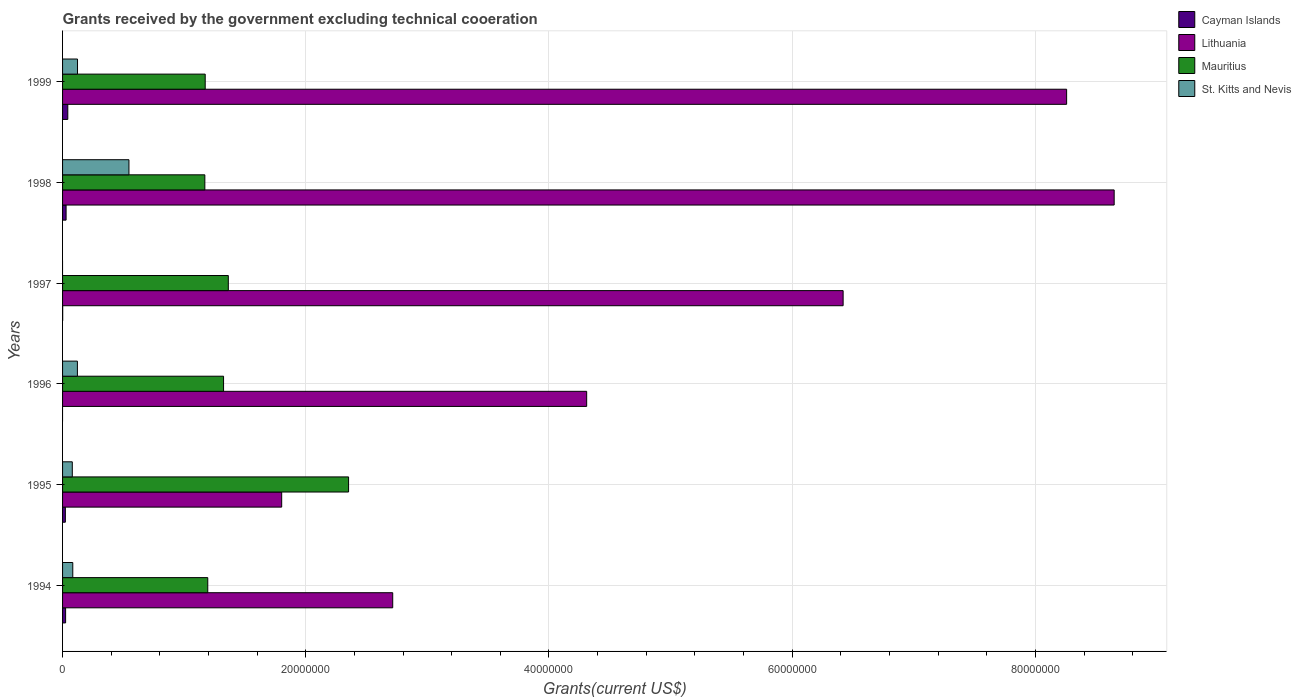How many groups of bars are there?
Make the answer very short. 6. Are the number of bars per tick equal to the number of legend labels?
Provide a short and direct response. No. Are the number of bars on each tick of the Y-axis equal?
Ensure brevity in your answer.  No. In how many cases, is the number of bars for a given year not equal to the number of legend labels?
Provide a short and direct response. 2. What is the total grants received by the government in Cayman Islands in 1995?
Your answer should be very brief. 2.30e+05. Across all years, what is the minimum total grants received by the government in Lithuania?
Your answer should be compact. 1.80e+07. What is the total total grants received by the government in Lithuania in the graph?
Make the answer very short. 3.22e+08. What is the difference between the total grants received by the government in Mauritius in 1996 and that in 1999?
Make the answer very short. 1.51e+06. What is the difference between the total grants received by the government in Mauritius in 1994 and the total grants received by the government in St. Kitts and Nevis in 1997?
Offer a very short reply. 1.19e+07. What is the average total grants received by the government in St. Kitts and Nevis per year?
Provide a succinct answer. 1.59e+06. In the year 1995, what is the difference between the total grants received by the government in Lithuania and total grants received by the government in Cayman Islands?
Keep it short and to the point. 1.78e+07. What is the ratio of the total grants received by the government in Lithuania in 1997 to that in 1998?
Provide a short and direct response. 0.74. Is the total grants received by the government in Cayman Islands in 1995 less than that in 1997?
Offer a terse response. No. What is the difference between the highest and the second highest total grants received by the government in Mauritius?
Your answer should be very brief. 9.89e+06. What is the difference between the highest and the lowest total grants received by the government in Lithuania?
Your answer should be very brief. 6.85e+07. Is it the case that in every year, the sum of the total grants received by the government in Lithuania and total grants received by the government in Mauritius is greater than the sum of total grants received by the government in St. Kitts and Nevis and total grants received by the government in Cayman Islands?
Offer a terse response. Yes. Is it the case that in every year, the sum of the total grants received by the government in Cayman Islands and total grants received by the government in Mauritius is greater than the total grants received by the government in St. Kitts and Nevis?
Make the answer very short. Yes. Are all the bars in the graph horizontal?
Offer a very short reply. Yes. Does the graph contain any zero values?
Keep it short and to the point. Yes. Does the graph contain grids?
Keep it short and to the point. Yes. What is the title of the graph?
Make the answer very short. Grants received by the government excluding technical cooeration. What is the label or title of the X-axis?
Ensure brevity in your answer.  Grants(current US$). What is the label or title of the Y-axis?
Your response must be concise. Years. What is the Grants(current US$) of Cayman Islands in 1994?
Keep it short and to the point. 2.50e+05. What is the Grants(current US$) of Lithuania in 1994?
Your answer should be very brief. 2.72e+07. What is the Grants(current US$) in Mauritius in 1994?
Offer a terse response. 1.19e+07. What is the Grants(current US$) in St. Kitts and Nevis in 1994?
Keep it short and to the point. 8.40e+05. What is the Grants(current US$) in Lithuania in 1995?
Make the answer very short. 1.80e+07. What is the Grants(current US$) in Mauritius in 1995?
Your answer should be compact. 2.35e+07. What is the Grants(current US$) in Lithuania in 1996?
Your answer should be compact. 4.31e+07. What is the Grants(current US$) of Mauritius in 1996?
Ensure brevity in your answer.  1.32e+07. What is the Grants(current US$) in St. Kitts and Nevis in 1996?
Your answer should be very brief. 1.22e+06. What is the Grants(current US$) in Lithuania in 1997?
Your answer should be very brief. 6.42e+07. What is the Grants(current US$) in Mauritius in 1997?
Ensure brevity in your answer.  1.36e+07. What is the Grants(current US$) of Cayman Islands in 1998?
Your response must be concise. 2.90e+05. What is the Grants(current US$) in Lithuania in 1998?
Make the answer very short. 8.65e+07. What is the Grants(current US$) in Mauritius in 1998?
Give a very brief answer. 1.17e+07. What is the Grants(current US$) in St. Kitts and Nevis in 1998?
Provide a short and direct response. 5.46e+06. What is the Grants(current US$) of Lithuania in 1999?
Your response must be concise. 8.26e+07. What is the Grants(current US$) of Mauritius in 1999?
Your answer should be very brief. 1.17e+07. What is the Grants(current US$) of St. Kitts and Nevis in 1999?
Give a very brief answer. 1.23e+06. Across all years, what is the maximum Grants(current US$) in Cayman Islands?
Your response must be concise. 4.30e+05. Across all years, what is the maximum Grants(current US$) in Lithuania?
Offer a terse response. 8.65e+07. Across all years, what is the maximum Grants(current US$) of Mauritius?
Your answer should be compact. 2.35e+07. Across all years, what is the maximum Grants(current US$) in St. Kitts and Nevis?
Provide a succinct answer. 5.46e+06. Across all years, what is the minimum Grants(current US$) in Lithuania?
Provide a short and direct response. 1.80e+07. Across all years, what is the minimum Grants(current US$) in Mauritius?
Make the answer very short. 1.17e+07. What is the total Grants(current US$) of Cayman Islands in the graph?
Offer a very short reply. 1.21e+06. What is the total Grants(current US$) of Lithuania in the graph?
Your response must be concise. 3.22e+08. What is the total Grants(current US$) in Mauritius in the graph?
Make the answer very short. 8.58e+07. What is the total Grants(current US$) in St. Kitts and Nevis in the graph?
Offer a terse response. 9.55e+06. What is the difference between the Grants(current US$) in Cayman Islands in 1994 and that in 1995?
Your answer should be very brief. 2.00e+04. What is the difference between the Grants(current US$) in Lithuania in 1994 and that in 1995?
Ensure brevity in your answer.  9.13e+06. What is the difference between the Grants(current US$) of Mauritius in 1994 and that in 1995?
Offer a very short reply. -1.16e+07. What is the difference between the Grants(current US$) of St. Kitts and Nevis in 1994 and that in 1995?
Your answer should be compact. 4.00e+04. What is the difference between the Grants(current US$) of Lithuania in 1994 and that in 1996?
Provide a short and direct response. -1.60e+07. What is the difference between the Grants(current US$) in Mauritius in 1994 and that in 1996?
Provide a succinct answer. -1.30e+06. What is the difference between the Grants(current US$) in St. Kitts and Nevis in 1994 and that in 1996?
Provide a succinct answer. -3.80e+05. What is the difference between the Grants(current US$) of Cayman Islands in 1994 and that in 1997?
Give a very brief answer. 2.40e+05. What is the difference between the Grants(current US$) of Lithuania in 1994 and that in 1997?
Your response must be concise. -3.70e+07. What is the difference between the Grants(current US$) of Mauritius in 1994 and that in 1997?
Your answer should be compact. -1.69e+06. What is the difference between the Grants(current US$) in Cayman Islands in 1994 and that in 1998?
Give a very brief answer. -4.00e+04. What is the difference between the Grants(current US$) in Lithuania in 1994 and that in 1998?
Your answer should be very brief. -5.93e+07. What is the difference between the Grants(current US$) in St. Kitts and Nevis in 1994 and that in 1998?
Your response must be concise. -4.62e+06. What is the difference between the Grants(current US$) in Lithuania in 1994 and that in 1999?
Give a very brief answer. -5.54e+07. What is the difference between the Grants(current US$) of Mauritius in 1994 and that in 1999?
Keep it short and to the point. 2.10e+05. What is the difference between the Grants(current US$) in St. Kitts and Nevis in 1994 and that in 1999?
Provide a succinct answer. -3.90e+05. What is the difference between the Grants(current US$) in Lithuania in 1995 and that in 1996?
Make the answer very short. -2.51e+07. What is the difference between the Grants(current US$) in Mauritius in 1995 and that in 1996?
Provide a succinct answer. 1.03e+07. What is the difference between the Grants(current US$) of St. Kitts and Nevis in 1995 and that in 1996?
Your response must be concise. -4.20e+05. What is the difference between the Grants(current US$) of Cayman Islands in 1995 and that in 1997?
Make the answer very short. 2.20e+05. What is the difference between the Grants(current US$) in Lithuania in 1995 and that in 1997?
Make the answer very short. -4.62e+07. What is the difference between the Grants(current US$) of Mauritius in 1995 and that in 1997?
Provide a succinct answer. 9.89e+06. What is the difference between the Grants(current US$) of Lithuania in 1995 and that in 1998?
Keep it short and to the point. -6.85e+07. What is the difference between the Grants(current US$) in Mauritius in 1995 and that in 1998?
Offer a terse response. 1.18e+07. What is the difference between the Grants(current US$) of St. Kitts and Nevis in 1995 and that in 1998?
Your answer should be compact. -4.66e+06. What is the difference between the Grants(current US$) of Cayman Islands in 1995 and that in 1999?
Provide a succinct answer. -2.00e+05. What is the difference between the Grants(current US$) in Lithuania in 1995 and that in 1999?
Make the answer very short. -6.46e+07. What is the difference between the Grants(current US$) of Mauritius in 1995 and that in 1999?
Ensure brevity in your answer.  1.18e+07. What is the difference between the Grants(current US$) in St. Kitts and Nevis in 1995 and that in 1999?
Offer a terse response. -4.30e+05. What is the difference between the Grants(current US$) of Lithuania in 1996 and that in 1997?
Provide a short and direct response. -2.11e+07. What is the difference between the Grants(current US$) of Mauritius in 1996 and that in 1997?
Your answer should be very brief. -3.90e+05. What is the difference between the Grants(current US$) in Lithuania in 1996 and that in 1998?
Offer a terse response. -4.34e+07. What is the difference between the Grants(current US$) in Mauritius in 1996 and that in 1998?
Make the answer very short. 1.54e+06. What is the difference between the Grants(current US$) of St. Kitts and Nevis in 1996 and that in 1998?
Keep it short and to the point. -4.24e+06. What is the difference between the Grants(current US$) of Lithuania in 1996 and that in 1999?
Your answer should be compact. -3.95e+07. What is the difference between the Grants(current US$) of Mauritius in 1996 and that in 1999?
Offer a terse response. 1.51e+06. What is the difference between the Grants(current US$) in St. Kitts and Nevis in 1996 and that in 1999?
Make the answer very short. -10000. What is the difference between the Grants(current US$) in Cayman Islands in 1997 and that in 1998?
Your answer should be compact. -2.80e+05. What is the difference between the Grants(current US$) of Lithuania in 1997 and that in 1998?
Provide a succinct answer. -2.23e+07. What is the difference between the Grants(current US$) of Mauritius in 1997 and that in 1998?
Offer a terse response. 1.93e+06. What is the difference between the Grants(current US$) of Cayman Islands in 1997 and that in 1999?
Offer a very short reply. -4.20e+05. What is the difference between the Grants(current US$) in Lithuania in 1997 and that in 1999?
Your response must be concise. -1.84e+07. What is the difference between the Grants(current US$) in Mauritius in 1997 and that in 1999?
Your answer should be very brief. 1.90e+06. What is the difference between the Grants(current US$) in Cayman Islands in 1998 and that in 1999?
Offer a terse response. -1.40e+05. What is the difference between the Grants(current US$) of Lithuania in 1998 and that in 1999?
Provide a short and direct response. 3.91e+06. What is the difference between the Grants(current US$) in St. Kitts and Nevis in 1998 and that in 1999?
Offer a very short reply. 4.23e+06. What is the difference between the Grants(current US$) of Cayman Islands in 1994 and the Grants(current US$) of Lithuania in 1995?
Your answer should be compact. -1.78e+07. What is the difference between the Grants(current US$) in Cayman Islands in 1994 and the Grants(current US$) in Mauritius in 1995?
Your answer should be compact. -2.33e+07. What is the difference between the Grants(current US$) of Cayman Islands in 1994 and the Grants(current US$) of St. Kitts and Nevis in 1995?
Your answer should be very brief. -5.50e+05. What is the difference between the Grants(current US$) in Lithuania in 1994 and the Grants(current US$) in Mauritius in 1995?
Your answer should be very brief. 3.63e+06. What is the difference between the Grants(current US$) in Lithuania in 1994 and the Grants(current US$) in St. Kitts and Nevis in 1995?
Provide a short and direct response. 2.64e+07. What is the difference between the Grants(current US$) of Mauritius in 1994 and the Grants(current US$) of St. Kitts and Nevis in 1995?
Make the answer very short. 1.11e+07. What is the difference between the Grants(current US$) of Cayman Islands in 1994 and the Grants(current US$) of Lithuania in 1996?
Your answer should be compact. -4.28e+07. What is the difference between the Grants(current US$) of Cayman Islands in 1994 and the Grants(current US$) of Mauritius in 1996?
Provide a succinct answer. -1.30e+07. What is the difference between the Grants(current US$) of Cayman Islands in 1994 and the Grants(current US$) of St. Kitts and Nevis in 1996?
Your response must be concise. -9.70e+05. What is the difference between the Grants(current US$) in Lithuania in 1994 and the Grants(current US$) in Mauritius in 1996?
Offer a terse response. 1.39e+07. What is the difference between the Grants(current US$) of Lithuania in 1994 and the Grants(current US$) of St. Kitts and Nevis in 1996?
Your answer should be compact. 2.59e+07. What is the difference between the Grants(current US$) of Mauritius in 1994 and the Grants(current US$) of St. Kitts and Nevis in 1996?
Provide a succinct answer. 1.07e+07. What is the difference between the Grants(current US$) of Cayman Islands in 1994 and the Grants(current US$) of Lithuania in 1997?
Offer a terse response. -6.39e+07. What is the difference between the Grants(current US$) of Cayman Islands in 1994 and the Grants(current US$) of Mauritius in 1997?
Give a very brief answer. -1.34e+07. What is the difference between the Grants(current US$) in Lithuania in 1994 and the Grants(current US$) in Mauritius in 1997?
Your answer should be compact. 1.35e+07. What is the difference between the Grants(current US$) of Cayman Islands in 1994 and the Grants(current US$) of Lithuania in 1998?
Ensure brevity in your answer.  -8.62e+07. What is the difference between the Grants(current US$) of Cayman Islands in 1994 and the Grants(current US$) of Mauritius in 1998?
Ensure brevity in your answer.  -1.14e+07. What is the difference between the Grants(current US$) of Cayman Islands in 1994 and the Grants(current US$) of St. Kitts and Nevis in 1998?
Offer a terse response. -5.21e+06. What is the difference between the Grants(current US$) in Lithuania in 1994 and the Grants(current US$) in Mauritius in 1998?
Ensure brevity in your answer.  1.54e+07. What is the difference between the Grants(current US$) of Lithuania in 1994 and the Grants(current US$) of St. Kitts and Nevis in 1998?
Provide a succinct answer. 2.17e+07. What is the difference between the Grants(current US$) in Mauritius in 1994 and the Grants(current US$) in St. Kitts and Nevis in 1998?
Keep it short and to the point. 6.48e+06. What is the difference between the Grants(current US$) in Cayman Islands in 1994 and the Grants(current US$) in Lithuania in 1999?
Provide a succinct answer. -8.23e+07. What is the difference between the Grants(current US$) in Cayman Islands in 1994 and the Grants(current US$) in Mauritius in 1999?
Your answer should be very brief. -1.15e+07. What is the difference between the Grants(current US$) in Cayman Islands in 1994 and the Grants(current US$) in St. Kitts and Nevis in 1999?
Your response must be concise. -9.80e+05. What is the difference between the Grants(current US$) in Lithuania in 1994 and the Grants(current US$) in Mauritius in 1999?
Your answer should be very brief. 1.54e+07. What is the difference between the Grants(current US$) of Lithuania in 1994 and the Grants(current US$) of St. Kitts and Nevis in 1999?
Offer a terse response. 2.59e+07. What is the difference between the Grants(current US$) of Mauritius in 1994 and the Grants(current US$) of St. Kitts and Nevis in 1999?
Offer a terse response. 1.07e+07. What is the difference between the Grants(current US$) of Cayman Islands in 1995 and the Grants(current US$) of Lithuania in 1996?
Offer a terse response. -4.29e+07. What is the difference between the Grants(current US$) in Cayman Islands in 1995 and the Grants(current US$) in Mauritius in 1996?
Ensure brevity in your answer.  -1.30e+07. What is the difference between the Grants(current US$) in Cayman Islands in 1995 and the Grants(current US$) in St. Kitts and Nevis in 1996?
Provide a succinct answer. -9.90e+05. What is the difference between the Grants(current US$) in Lithuania in 1995 and the Grants(current US$) in Mauritius in 1996?
Ensure brevity in your answer.  4.78e+06. What is the difference between the Grants(current US$) of Lithuania in 1995 and the Grants(current US$) of St. Kitts and Nevis in 1996?
Provide a succinct answer. 1.68e+07. What is the difference between the Grants(current US$) of Mauritius in 1995 and the Grants(current US$) of St. Kitts and Nevis in 1996?
Offer a terse response. 2.23e+07. What is the difference between the Grants(current US$) in Cayman Islands in 1995 and the Grants(current US$) in Lithuania in 1997?
Offer a very short reply. -6.40e+07. What is the difference between the Grants(current US$) in Cayman Islands in 1995 and the Grants(current US$) in Mauritius in 1997?
Your response must be concise. -1.34e+07. What is the difference between the Grants(current US$) of Lithuania in 1995 and the Grants(current US$) of Mauritius in 1997?
Provide a succinct answer. 4.39e+06. What is the difference between the Grants(current US$) of Cayman Islands in 1995 and the Grants(current US$) of Lithuania in 1998?
Offer a terse response. -8.62e+07. What is the difference between the Grants(current US$) of Cayman Islands in 1995 and the Grants(current US$) of Mauritius in 1998?
Ensure brevity in your answer.  -1.15e+07. What is the difference between the Grants(current US$) in Cayman Islands in 1995 and the Grants(current US$) in St. Kitts and Nevis in 1998?
Ensure brevity in your answer.  -5.23e+06. What is the difference between the Grants(current US$) in Lithuania in 1995 and the Grants(current US$) in Mauritius in 1998?
Provide a succinct answer. 6.32e+06. What is the difference between the Grants(current US$) in Lithuania in 1995 and the Grants(current US$) in St. Kitts and Nevis in 1998?
Your answer should be compact. 1.26e+07. What is the difference between the Grants(current US$) of Mauritius in 1995 and the Grants(current US$) of St. Kitts and Nevis in 1998?
Provide a succinct answer. 1.81e+07. What is the difference between the Grants(current US$) in Cayman Islands in 1995 and the Grants(current US$) in Lithuania in 1999?
Offer a very short reply. -8.23e+07. What is the difference between the Grants(current US$) of Cayman Islands in 1995 and the Grants(current US$) of Mauritius in 1999?
Provide a succinct answer. -1.15e+07. What is the difference between the Grants(current US$) of Cayman Islands in 1995 and the Grants(current US$) of St. Kitts and Nevis in 1999?
Your answer should be compact. -1.00e+06. What is the difference between the Grants(current US$) in Lithuania in 1995 and the Grants(current US$) in Mauritius in 1999?
Provide a short and direct response. 6.29e+06. What is the difference between the Grants(current US$) in Lithuania in 1995 and the Grants(current US$) in St. Kitts and Nevis in 1999?
Your answer should be compact. 1.68e+07. What is the difference between the Grants(current US$) in Mauritius in 1995 and the Grants(current US$) in St. Kitts and Nevis in 1999?
Your response must be concise. 2.23e+07. What is the difference between the Grants(current US$) of Lithuania in 1996 and the Grants(current US$) of Mauritius in 1997?
Keep it short and to the point. 2.95e+07. What is the difference between the Grants(current US$) in Lithuania in 1996 and the Grants(current US$) in Mauritius in 1998?
Provide a short and direct response. 3.14e+07. What is the difference between the Grants(current US$) of Lithuania in 1996 and the Grants(current US$) of St. Kitts and Nevis in 1998?
Provide a succinct answer. 3.76e+07. What is the difference between the Grants(current US$) of Mauritius in 1996 and the Grants(current US$) of St. Kitts and Nevis in 1998?
Offer a very short reply. 7.78e+06. What is the difference between the Grants(current US$) in Lithuania in 1996 and the Grants(current US$) in Mauritius in 1999?
Your answer should be compact. 3.14e+07. What is the difference between the Grants(current US$) in Lithuania in 1996 and the Grants(current US$) in St. Kitts and Nevis in 1999?
Make the answer very short. 4.19e+07. What is the difference between the Grants(current US$) of Mauritius in 1996 and the Grants(current US$) of St. Kitts and Nevis in 1999?
Ensure brevity in your answer.  1.20e+07. What is the difference between the Grants(current US$) of Cayman Islands in 1997 and the Grants(current US$) of Lithuania in 1998?
Keep it short and to the point. -8.65e+07. What is the difference between the Grants(current US$) of Cayman Islands in 1997 and the Grants(current US$) of Mauritius in 1998?
Make the answer very short. -1.17e+07. What is the difference between the Grants(current US$) in Cayman Islands in 1997 and the Grants(current US$) in St. Kitts and Nevis in 1998?
Your response must be concise. -5.45e+06. What is the difference between the Grants(current US$) in Lithuania in 1997 and the Grants(current US$) in Mauritius in 1998?
Keep it short and to the point. 5.25e+07. What is the difference between the Grants(current US$) of Lithuania in 1997 and the Grants(current US$) of St. Kitts and Nevis in 1998?
Ensure brevity in your answer.  5.87e+07. What is the difference between the Grants(current US$) in Mauritius in 1997 and the Grants(current US$) in St. Kitts and Nevis in 1998?
Provide a succinct answer. 8.17e+06. What is the difference between the Grants(current US$) of Cayman Islands in 1997 and the Grants(current US$) of Lithuania in 1999?
Ensure brevity in your answer.  -8.26e+07. What is the difference between the Grants(current US$) in Cayman Islands in 1997 and the Grants(current US$) in Mauritius in 1999?
Provide a short and direct response. -1.17e+07. What is the difference between the Grants(current US$) in Cayman Islands in 1997 and the Grants(current US$) in St. Kitts and Nevis in 1999?
Your response must be concise. -1.22e+06. What is the difference between the Grants(current US$) in Lithuania in 1997 and the Grants(current US$) in Mauritius in 1999?
Give a very brief answer. 5.25e+07. What is the difference between the Grants(current US$) of Lithuania in 1997 and the Grants(current US$) of St. Kitts and Nevis in 1999?
Keep it short and to the point. 6.30e+07. What is the difference between the Grants(current US$) of Mauritius in 1997 and the Grants(current US$) of St. Kitts and Nevis in 1999?
Offer a very short reply. 1.24e+07. What is the difference between the Grants(current US$) in Cayman Islands in 1998 and the Grants(current US$) in Lithuania in 1999?
Your response must be concise. -8.23e+07. What is the difference between the Grants(current US$) of Cayman Islands in 1998 and the Grants(current US$) of Mauritius in 1999?
Keep it short and to the point. -1.14e+07. What is the difference between the Grants(current US$) in Cayman Islands in 1998 and the Grants(current US$) in St. Kitts and Nevis in 1999?
Offer a terse response. -9.40e+05. What is the difference between the Grants(current US$) of Lithuania in 1998 and the Grants(current US$) of Mauritius in 1999?
Give a very brief answer. 7.48e+07. What is the difference between the Grants(current US$) in Lithuania in 1998 and the Grants(current US$) in St. Kitts and Nevis in 1999?
Make the answer very short. 8.52e+07. What is the difference between the Grants(current US$) in Mauritius in 1998 and the Grants(current US$) in St. Kitts and Nevis in 1999?
Your answer should be compact. 1.05e+07. What is the average Grants(current US$) of Cayman Islands per year?
Your answer should be very brief. 2.02e+05. What is the average Grants(current US$) of Lithuania per year?
Keep it short and to the point. 5.36e+07. What is the average Grants(current US$) in Mauritius per year?
Your answer should be very brief. 1.43e+07. What is the average Grants(current US$) of St. Kitts and Nevis per year?
Offer a very short reply. 1.59e+06. In the year 1994, what is the difference between the Grants(current US$) of Cayman Islands and Grants(current US$) of Lithuania?
Your answer should be compact. -2.69e+07. In the year 1994, what is the difference between the Grants(current US$) of Cayman Islands and Grants(current US$) of Mauritius?
Make the answer very short. -1.17e+07. In the year 1994, what is the difference between the Grants(current US$) of Cayman Islands and Grants(current US$) of St. Kitts and Nevis?
Make the answer very short. -5.90e+05. In the year 1994, what is the difference between the Grants(current US$) in Lithuania and Grants(current US$) in Mauritius?
Your answer should be compact. 1.52e+07. In the year 1994, what is the difference between the Grants(current US$) in Lithuania and Grants(current US$) in St. Kitts and Nevis?
Provide a short and direct response. 2.63e+07. In the year 1994, what is the difference between the Grants(current US$) of Mauritius and Grants(current US$) of St. Kitts and Nevis?
Give a very brief answer. 1.11e+07. In the year 1995, what is the difference between the Grants(current US$) in Cayman Islands and Grants(current US$) in Lithuania?
Your answer should be very brief. -1.78e+07. In the year 1995, what is the difference between the Grants(current US$) of Cayman Islands and Grants(current US$) of Mauritius?
Keep it short and to the point. -2.33e+07. In the year 1995, what is the difference between the Grants(current US$) in Cayman Islands and Grants(current US$) in St. Kitts and Nevis?
Make the answer very short. -5.70e+05. In the year 1995, what is the difference between the Grants(current US$) of Lithuania and Grants(current US$) of Mauritius?
Offer a very short reply. -5.50e+06. In the year 1995, what is the difference between the Grants(current US$) of Lithuania and Grants(current US$) of St. Kitts and Nevis?
Provide a short and direct response. 1.72e+07. In the year 1995, what is the difference between the Grants(current US$) in Mauritius and Grants(current US$) in St. Kitts and Nevis?
Keep it short and to the point. 2.27e+07. In the year 1996, what is the difference between the Grants(current US$) of Lithuania and Grants(current US$) of Mauritius?
Your answer should be compact. 2.99e+07. In the year 1996, what is the difference between the Grants(current US$) in Lithuania and Grants(current US$) in St. Kitts and Nevis?
Give a very brief answer. 4.19e+07. In the year 1996, what is the difference between the Grants(current US$) of Mauritius and Grants(current US$) of St. Kitts and Nevis?
Make the answer very short. 1.20e+07. In the year 1997, what is the difference between the Grants(current US$) in Cayman Islands and Grants(current US$) in Lithuania?
Give a very brief answer. -6.42e+07. In the year 1997, what is the difference between the Grants(current US$) in Cayman Islands and Grants(current US$) in Mauritius?
Provide a succinct answer. -1.36e+07. In the year 1997, what is the difference between the Grants(current US$) in Lithuania and Grants(current US$) in Mauritius?
Your answer should be very brief. 5.06e+07. In the year 1998, what is the difference between the Grants(current US$) of Cayman Islands and Grants(current US$) of Lithuania?
Offer a terse response. -8.62e+07. In the year 1998, what is the difference between the Grants(current US$) of Cayman Islands and Grants(current US$) of Mauritius?
Your answer should be compact. -1.14e+07. In the year 1998, what is the difference between the Grants(current US$) of Cayman Islands and Grants(current US$) of St. Kitts and Nevis?
Ensure brevity in your answer.  -5.17e+06. In the year 1998, what is the difference between the Grants(current US$) in Lithuania and Grants(current US$) in Mauritius?
Make the answer very short. 7.48e+07. In the year 1998, what is the difference between the Grants(current US$) in Lithuania and Grants(current US$) in St. Kitts and Nevis?
Give a very brief answer. 8.10e+07. In the year 1998, what is the difference between the Grants(current US$) in Mauritius and Grants(current US$) in St. Kitts and Nevis?
Your answer should be compact. 6.24e+06. In the year 1999, what is the difference between the Grants(current US$) of Cayman Islands and Grants(current US$) of Lithuania?
Your answer should be compact. -8.21e+07. In the year 1999, what is the difference between the Grants(current US$) of Cayman Islands and Grants(current US$) of Mauritius?
Your response must be concise. -1.13e+07. In the year 1999, what is the difference between the Grants(current US$) of Cayman Islands and Grants(current US$) of St. Kitts and Nevis?
Give a very brief answer. -8.00e+05. In the year 1999, what is the difference between the Grants(current US$) of Lithuania and Grants(current US$) of Mauritius?
Offer a terse response. 7.08e+07. In the year 1999, what is the difference between the Grants(current US$) of Lithuania and Grants(current US$) of St. Kitts and Nevis?
Provide a short and direct response. 8.13e+07. In the year 1999, what is the difference between the Grants(current US$) of Mauritius and Grants(current US$) of St. Kitts and Nevis?
Your answer should be compact. 1.05e+07. What is the ratio of the Grants(current US$) of Cayman Islands in 1994 to that in 1995?
Your answer should be compact. 1.09. What is the ratio of the Grants(current US$) in Lithuania in 1994 to that in 1995?
Make the answer very short. 1.51. What is the ratio of the Grants(current US$) in Mauritius in 1994 to that in 1995?
Make the answer very short. 0.51. What is the ratio of the Grants(current US$) in St. Kitts and Nevis in 1994 to that in 1995?
Ensure brevity in your answer.  1.05. What is the ratio of the Grants(current US$) in Lithuania in 1994 to that in 1996?
Your answer should be very brief. 0.63. What is the ratio of the Grants(current US$) of Mauritius in 1994 to that in 1996?
Provide a succinct answer. 0.9. What is the ratio of the Grants(current US$) in St. Kitts and Nevis in 1994 to that in 1996?
Provide a short and direct response. 0.69. What is the ratio of the Grants(current US$) of Lithuania in 1994 to that in 1997?
Make the answer very short. 0.42. What is the ratio of the Grants(current US$) of Mauritius in 1994 to that in 1997?
Give a very brief answer. 0.88. What is the ratio of the Grants(current US$) in Cayman Islands in 1994 to that in 1998?
Keep it short and to the point. 0.86. What is the ratio of the Grants(current US$) of Lithuania in 1994 to that in 1998?
Give a very brief answer. 0.31. What is the ratio of the Grants(current US$) in Mauritius in 1994 to that in 1998?
Provide a succinct answer. 1.02. What is the ratio of the Grants(current US$) in St. Kitts and Nevis in 1994 to that in 1998?
Provide a short and direct response. 0.15. What is the ratio of the Grants(current US$) in Cayman Islands in 1994 to that in 1999?
Make the answer very short. 0.58. What is the ratio of the Grants(current US$) of Lithuania in 1994 to that in 1999?
Give a very brief answer. 0.33. What is the ratio of the Grants(current US$) of Mauritius in 1994 to that in 1999?
Offer a terse response. 1.02. What is the ratio of the Grants(current US$) in St. Kitts and Nevis in 1994 to that in 1999?
Give a very brief answer. 0.68. What is the ratio of the Grants(current US$) in Lithuania in 1995 to that in 1996?
Your answer should be compact. 0.42. What is the ratio of the Grants(current US$) in Mauritius in 1995 to that in 1996?
Provide a short and direct response. 1.78. What is the ratio of the Grants(current US$) in St. Kitts and Nevis in 1995 to that in 1996?
Make the answer very short. 0.66. What is the ratio of the Grants(current US$) in Cayman Islands in 1995 to that in 1997?
Offer a very short reply. 23. What is the ratio of the Grants(current US$) of Lithuania in 1995 to that in 1997?
Your response must be concise. 0.28. What is the ratio of the Grants(current US$) of Mauritius in 1995 to that in 1997?
Provide a succinct answer. 1.73. What is the ratio of the Grants(current US$) of Cayman Islands in 1995 to that in 1998?
Offer a very short reply. 0.79. What is the ratio of the Grants(current US$) in Lithuania in 1995 to that in 1998?
Your answer should be compact. 0.21. What is the ratio of the Grants(current US$) of Mauritius in 1995 to that in 1998?
Provide a short and direct response. 2.01. What is the ratio of the Grants(current US$) in St. Kitts and Nevis in 1995 to that in 1998?
Keep it short and to the point. 0.15. What is the ratio of the Grants(current US$) of Cayman Islands in 1995 to that in 1999?
Your answer should be very brief. 0.53. What is the ratio of the Grants(current US$) of Lithuania in 1995 to that in 1999?
Give a very brief answer. 0.22. What is the ratio of the Grants(current US$) of Mauritius in 1995 to that in 1999?
Ensure brevity in your answer.  2.01. What is the ratio of the Grants(current US$) in St. Kitts and Nevis in 1995 to that in 1999?
Your answer should be compact. 0.65. What is the ratio of the Grants(current US$) in Lithuania in 1996 to that in 1997?
Your answer should be compact. 0.67. What is the ratio of the Grants(current US$) in Mauritius in 1996 to that in 1997?
Offer a terse response. 0.97. What is the ratio of the Grants(current US$) in Lithuania in 1996 to that in 1998?
Offer a terse response. 0.5. What is the ratio of the Grants(current US$) of Mauritius in 1996 to that in 1998?
Provide a succinct answer. 1.13. What is the ratio of the Grants(current US$) in St. Kitts and Nevis in 1996 to that in 1998?
Your response must be concise. 0.22. What is the ratio of the Grants(current US$) of Lithuania in 1996 to that in 1999?
Offer a very short reply. 0.52. What is the ratio of the Grants(current US$) in Mauritius in 1996 to that in 1999?
Your answer should be very brief. 1.13. What is the ratio of the Grants(current US$) in St. Kitts and Nevis in 1996 to that in 1999?
Offer a very short reply. 0.99. What is the ratio of the Grants(current US$) of Cayman Islands in 1997 to that in 1998?
Give a very brief answer. 0.03. What is the ratio of the Grants(current US$) of Lithuania in 1997 to that in 1998?
Provide a short and direct response. 0.74. What is the ratio of the Grants(current US$) in Mauritius in 1997 to that in 1998?
Give a very brief answer. 1.17. What is the ratio of the Grants(current US$) of Cayman Islands in 1997 to that in 1999?
Your response must be concise. 0.02. What is the ratio of the Grants(current US$) in Lithuania in 1997 to that in 1999?
Provide a short and direct response. 0.78. What is the ratio of the Grants(current US$) of Mauritius in 1997 to that in 1999?
Give a very brief answer. 1.16. What is the ratio of the Grants(current US$) in Cayman Islands in 1998 to that in 1999?
Offer a terse response. 0.67. What is the ratio of the Grants(current US$) in Lithuania in 1998 to that in 1999?
Make the answer very short. 1.05. What is the ratio of the Grants(current US$) of St. Kitts and Nevis in 1998 to that in 1999?
Offer a terse response. 4.44. What is the difference between the highest and the second highest Grants(current US$) in Cayman Islands?
Your answer should be compact. 1.40e+05. What is the difference between the highest and the second highest Grants(current US$) in Lithuania?
Your response must be concise. 3.91e+06. What is the difference between the highest and the second highest Grants(current US$) of Mauritius?
Make the answer very short. 9.89e+06. What is the difference between the highest and the second highest Grants(current US$) in St. Kitts and Nevis?
Keep it short and to the point. 4.23e+06. What is the difference between the highest and the lowest Grants(current US$) of Lithuania?
Your response must be concise. 6.85e+07. What is the difference between the highest and the lowest Grants(current US$) of Mauritius?
Make the answer very short. 1.18e+07. What is the difference between the highest and the lowest Grants(current US$) of St. Kitts and Nevis?
Keep it short and to the point. 5.46e+06. 